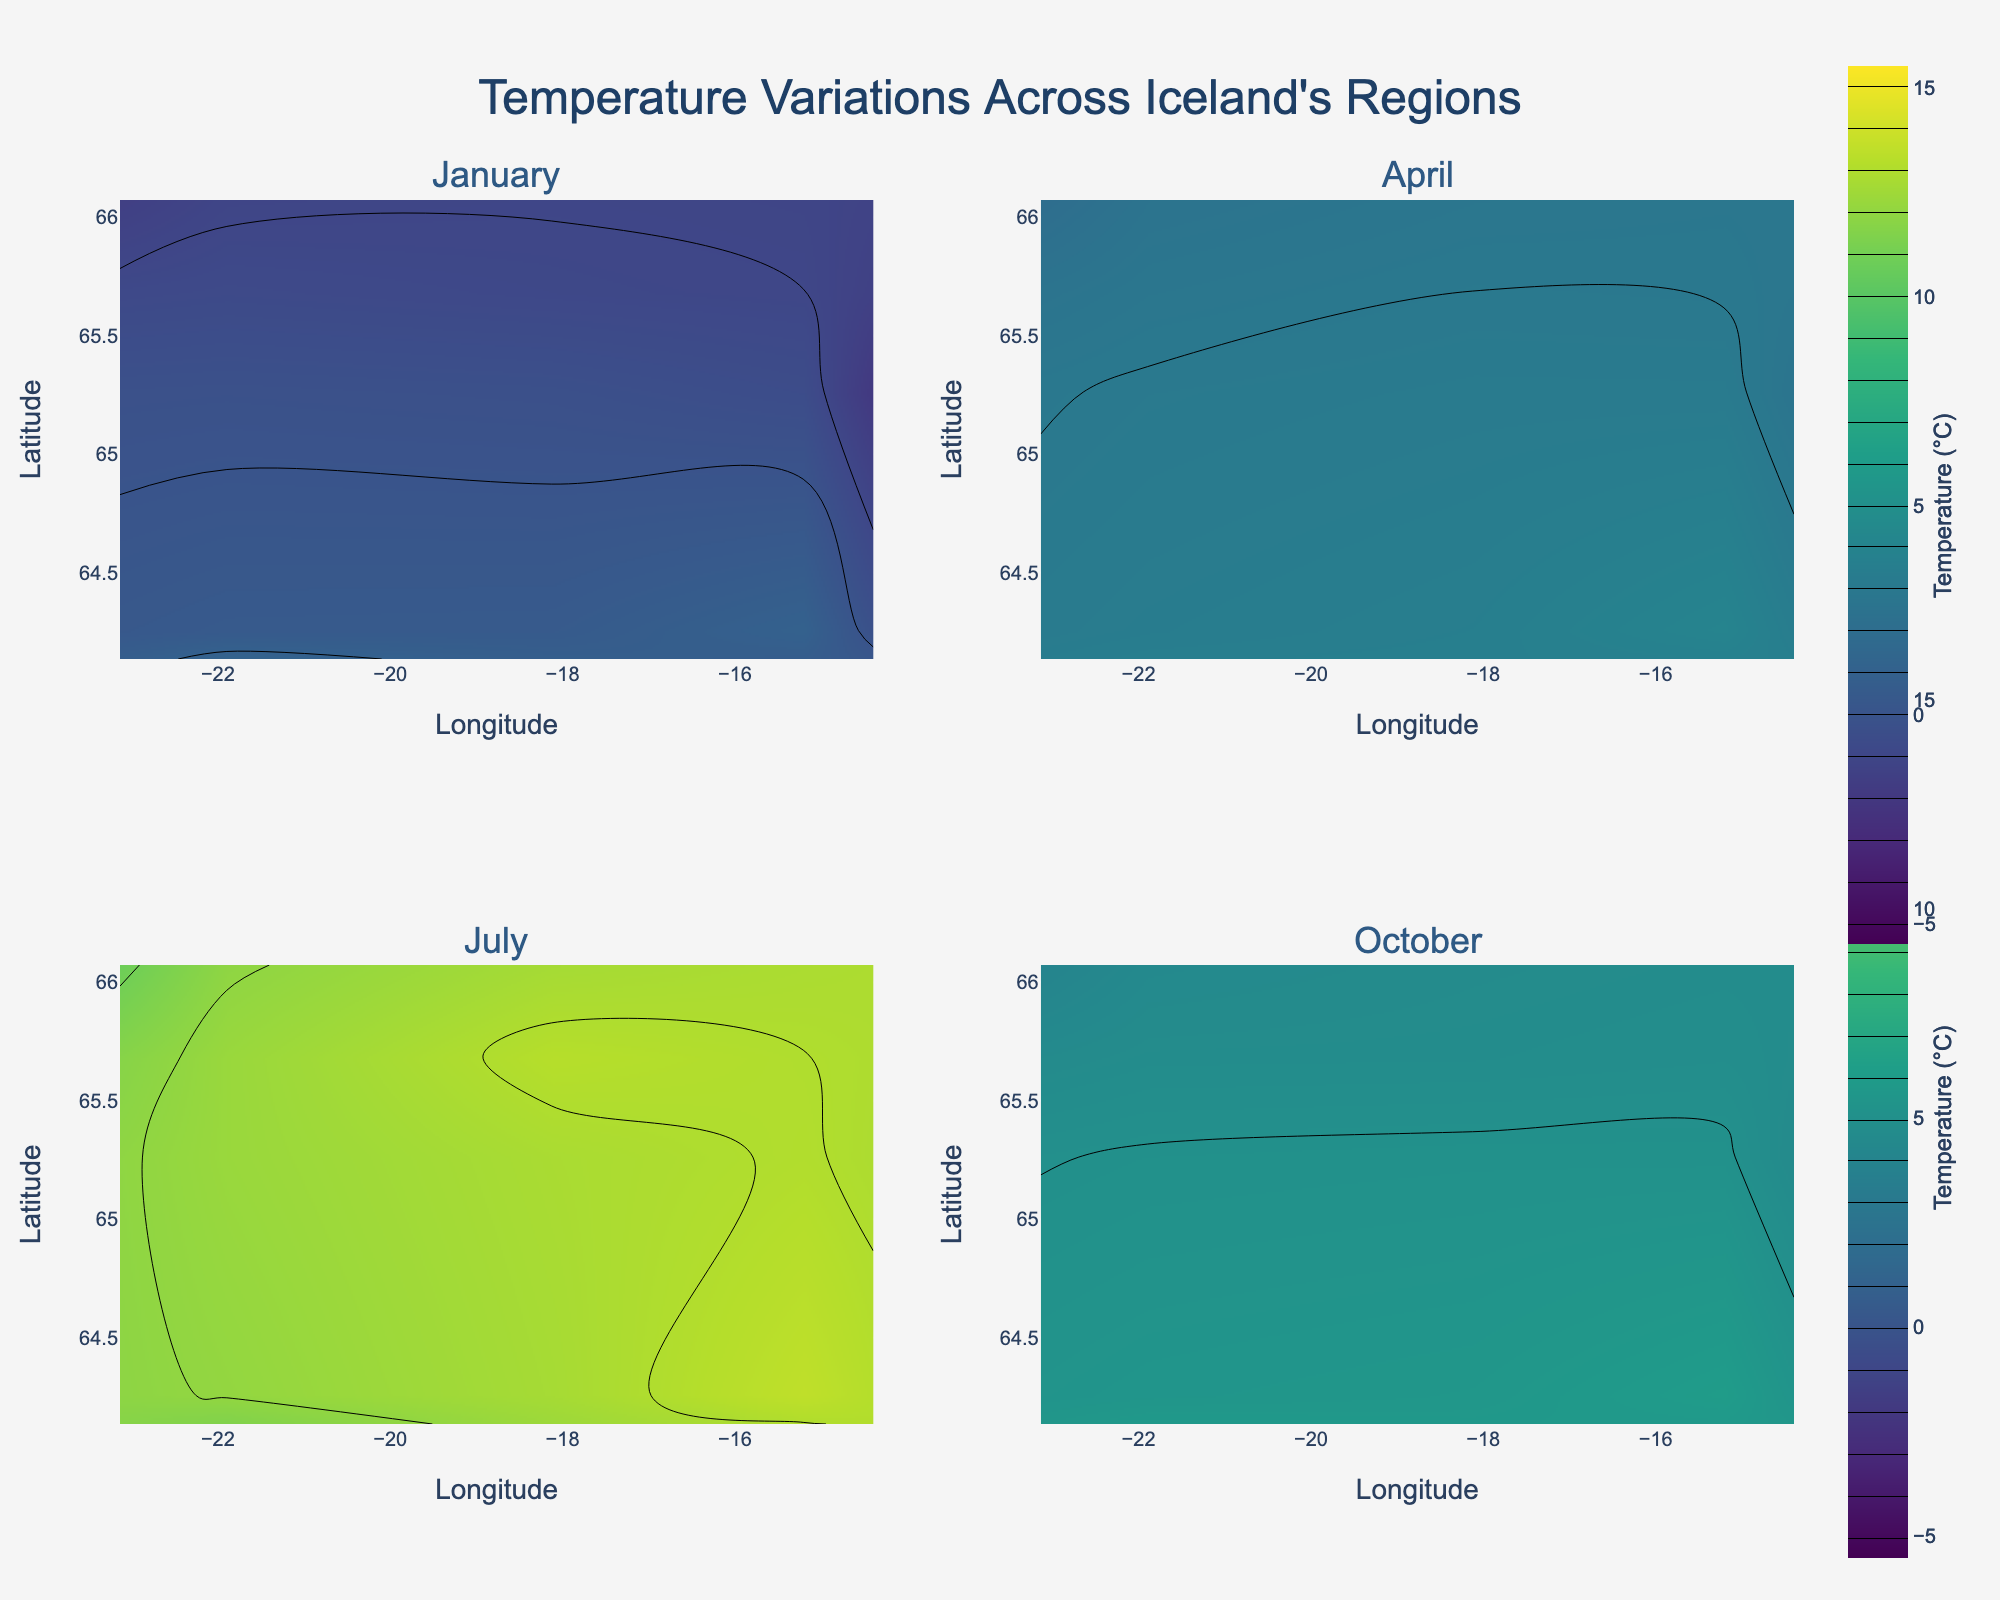What is the title of the figure? The title is prominently displayed at the top of the figure and is usually the largest text, providing an overview of what the figure represents.
Answer: Temperature Variations Across Iceland's Regions Which month shows the highest overall temperatures? This can be determined by comparing the temperature ranges in each subplot for the four months.
Answer: July What color represents the coldest temperatures in the figure? The figure uses a color scale to represent temperatures. The coldest temperatures are often represented by the darkest shades in a 'Viridis' color scale.
Answer: Dark purple What are the temperature ranges in January across Iceland? The January subplot shows contours with specific temperature values. Checking the contour lines will give a range of temperatures.
Answer: -2°C to 1.2°C In which regions is the temperature close to freezing in October? Observing the October subplot, look for contour lines near 0°C and note the latitude and longitude coordinates.
Answer: Ísafjörður and Egilsstaðir Which region generally has the highest temperatures in July? This can be determined by identifying the region with the highest contour values within the July subplot.
Answer: Höfn Compare the temperature variations between Reykjavik and Akureyri in April? By examining April's subplot and comparing the contour lines over the coordinates of Reykjavik and Akureyri, one can see which city has higher or lower temperatures.
Answer: Reykjavik is slightly warmer How do temperatures in Reykjavík vary between January and October? This requires comparing the January and October subplots, focusing on Reykjavik's coordinates to observe the temperature change.
Answer: From 1.2°C in January to 5.8°C in October Which month has the widest temperature range across Iceland? By checking all subplots, identify the month with the largest difference between the highest and lowest contour values.
Answer: January What is the latitude and longitude of the region with the highest temperature in the entire data set? Examine all subplots, identify the highest temperature contour, and note the corresponding latitude and longitude.
Answer: Höfn at 64.2555, -15.2084 in July 